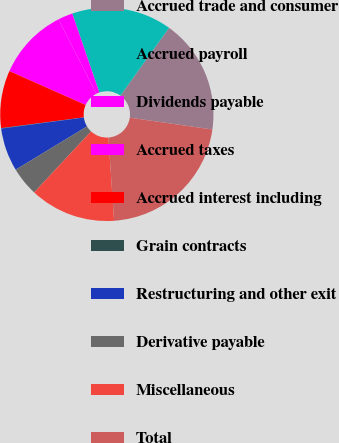Convert chart to OTSL. <chart><loc_0><loc_0><loc_500><loc_500><pie_chart><fcel>Accrued trade and consumer<fcel>Accrued payroll<fcel>Dividends payable<fcel>Accrued taxes<fcel>Accrued interest including<fcel>Grain contracts<fcel>Restructuring and other exit<fcel>Derivative payable<fcel>Miscellaneous<fcel>Total<nl><fcel>17.34%<fcel>15.18%<fcel>2.23%<fcel>10.86%<fcel>8.71%<fcel>0.07%<fcel>6.55%<fcel>4.39%<fcel>13.02%<fcel>21.65%<nl></chart> 